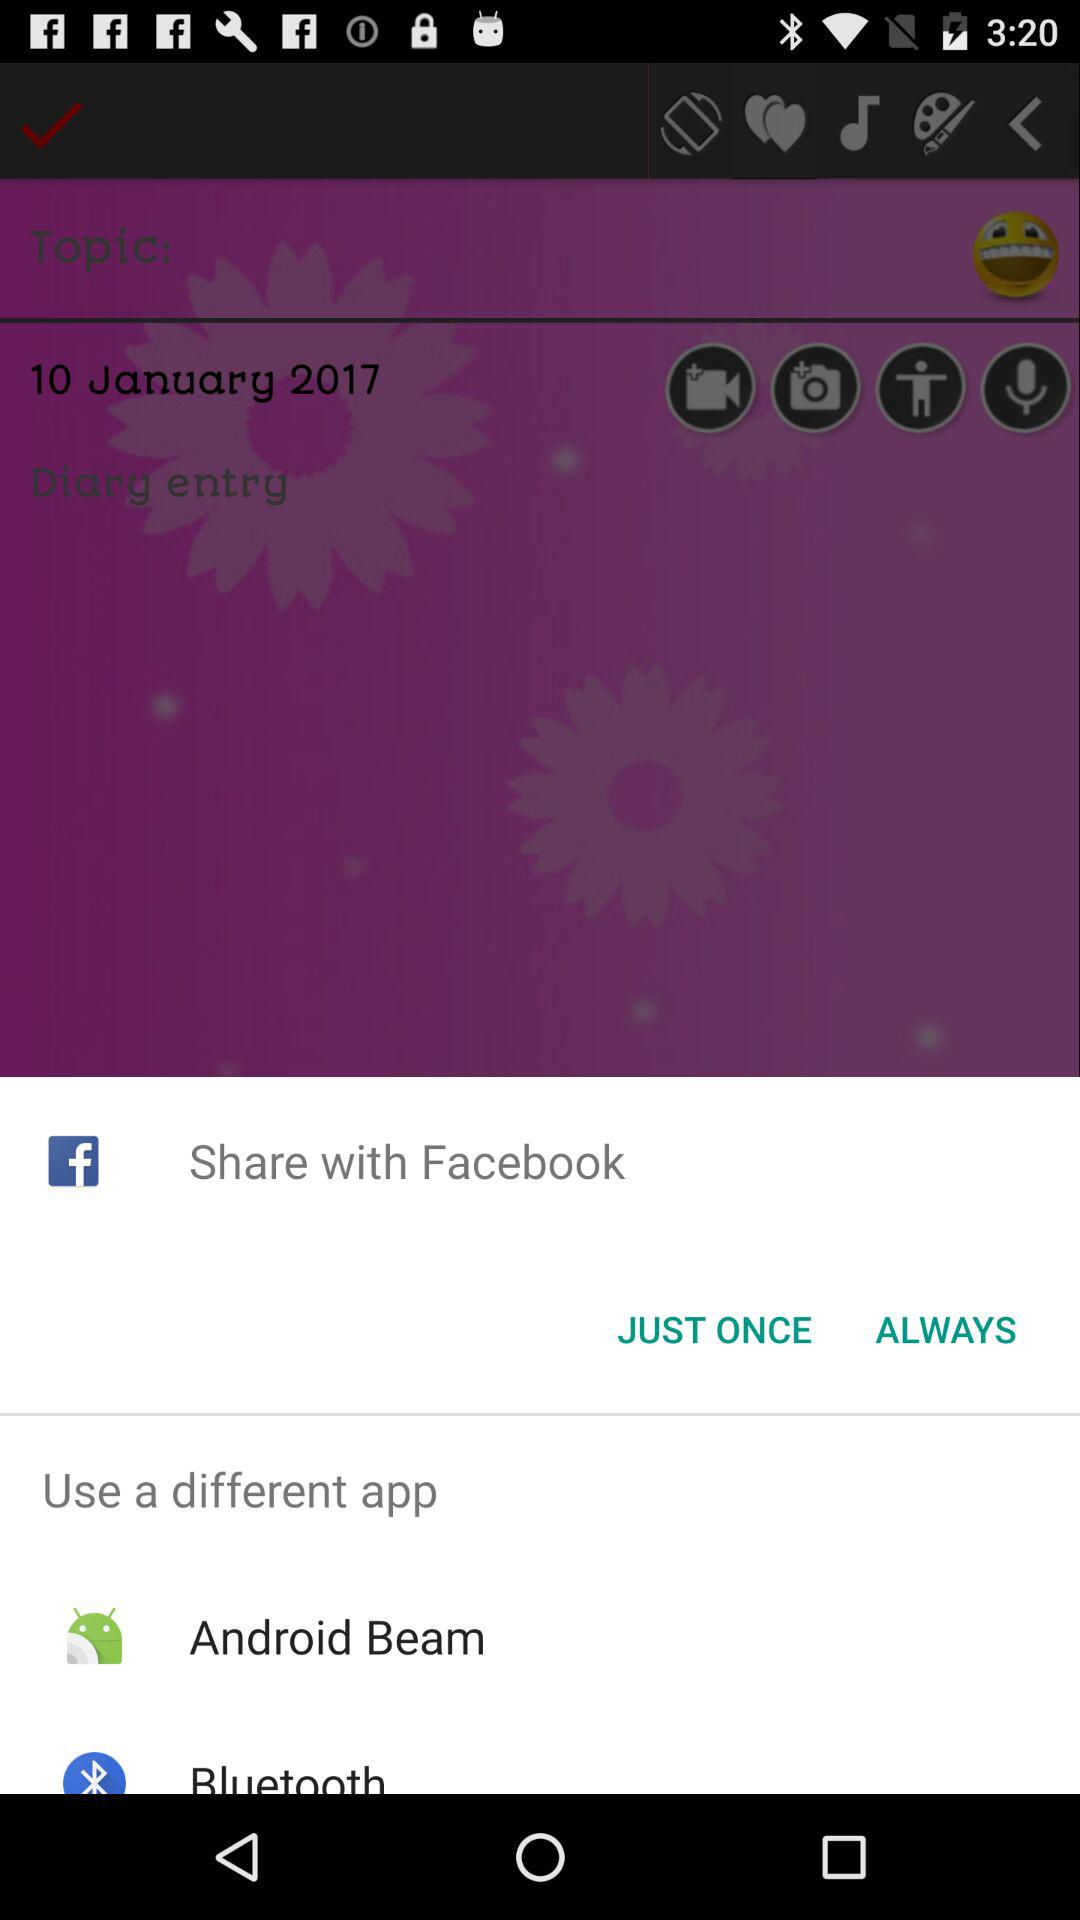Through what applications can we share the topic? The applications are "Facebook", "Android Beam" and "Bluetooth". 